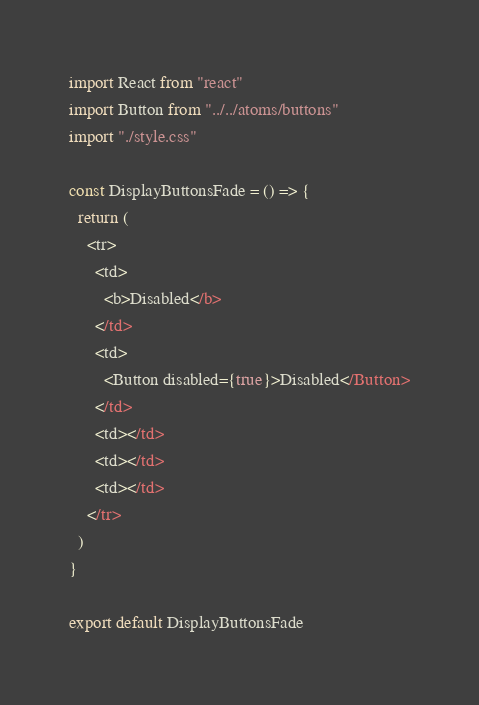Convert code to text. <code><loc_0><loc_0><loc_500><loc_500><_JavaScript_>import React from "react"
import Button from "../../atoms/buttons"
import "./style.css"

const DisplayButtonsFade = () => {
  return (
    <tr>
      <td>
        <b>Disabled</b>
      </td>
      <td>
        <Button disabled={true}>Disabled</Button>
      </td>
      <td></td>
      <td></td>
      <td></td>
    </tr>
  )
}

export default DisplayButtonsFade
</code> 